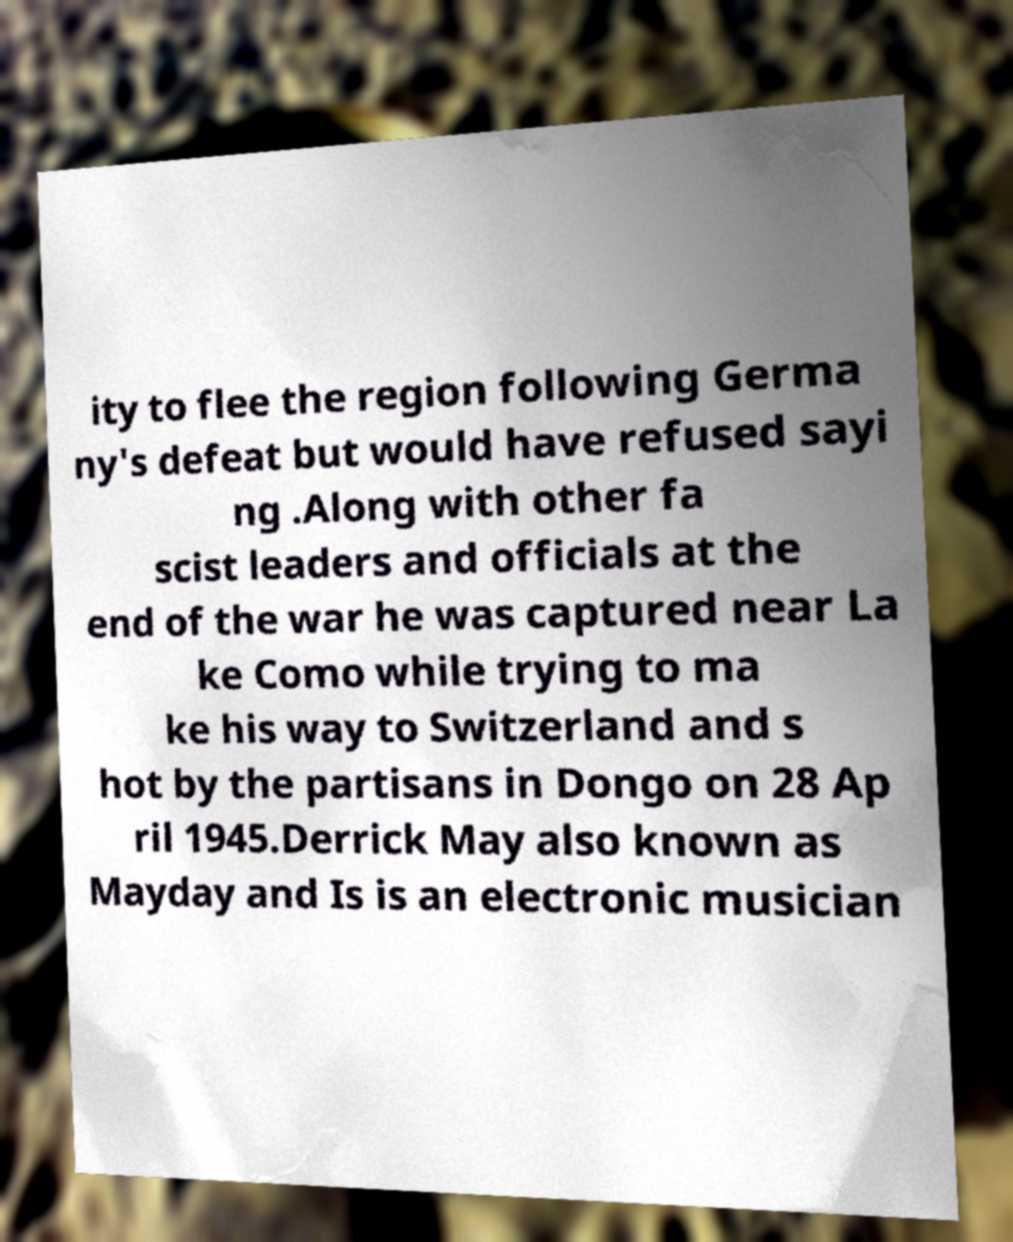Could you extract and type out the text from this image? ity to flee the region following Germa ny's defeat but would have refused sayi ng .Along with other fa scist leaders and officials at the end of the war he was captured near La ke Como while trying to ma ke his way to Switzerland and s hot by the partisans in Dongo on 28 Ap ril 1945.Derrick May also known as Mayday and Is is an electronic musician 